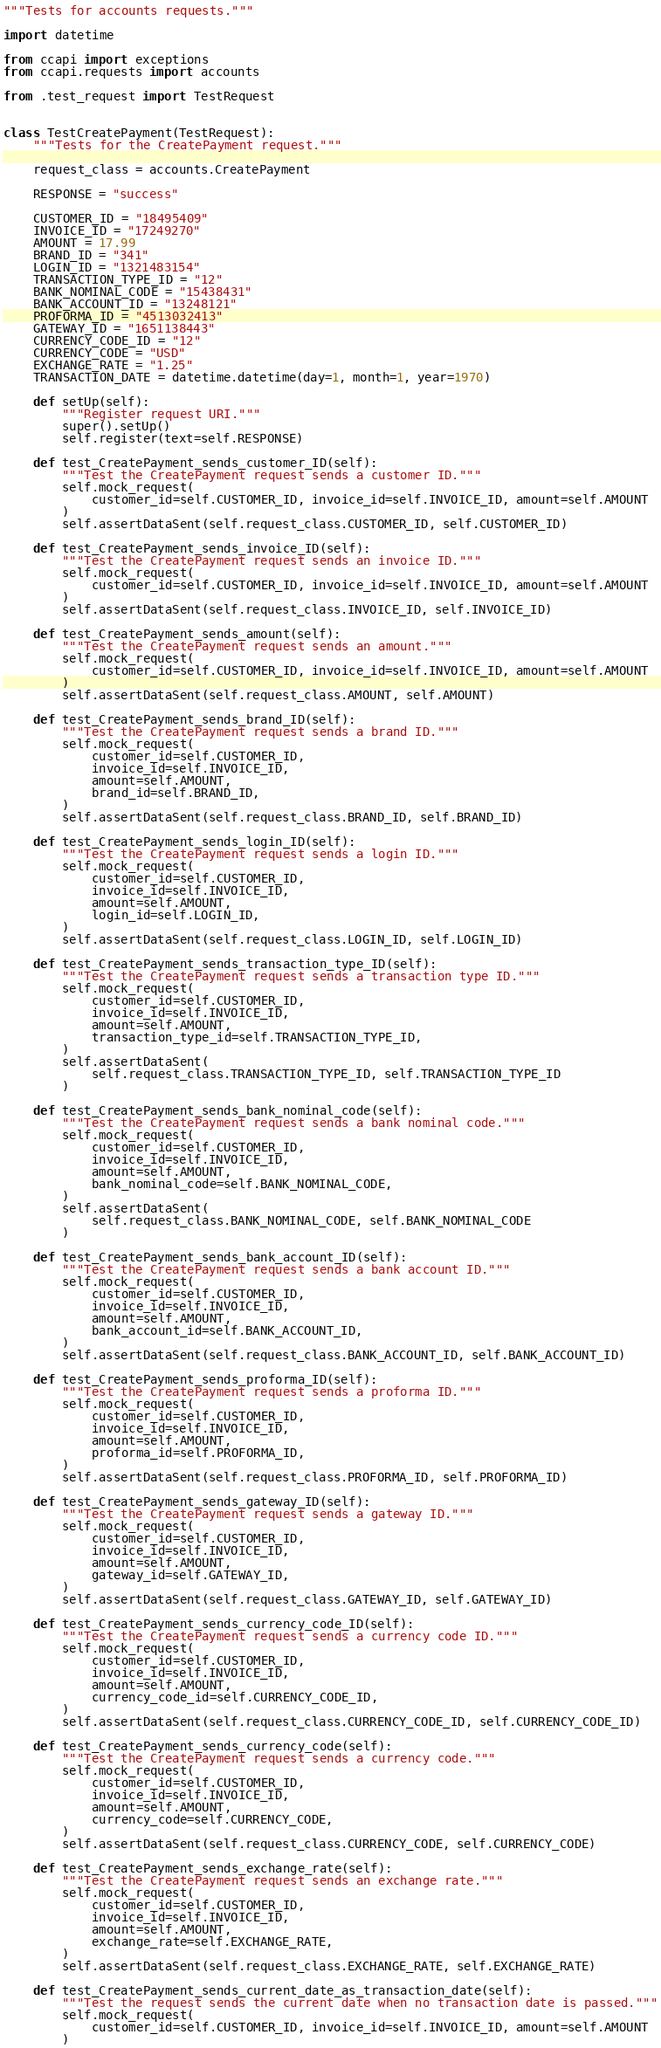Convert code to text. <code><loc_0><loc_0><loc_500><loc_500><_Python_>"""Tests for accounts requests."""

import datetime

from ccapi import exceptions
from ccapi.requests import accounts

from .test_request import TestRequest


class TestCreatePayment(TestRequest):
    """Tests for the CreatePayment request."""

    request_class = accounts.CreatePayment

    RESPONSE = "success"

    CUSTOMER_ID = "18495409"
    INVOICE_ID = "17249270"
    AMOUNT = 17.99
    BRAND_ID = "341"
    LOGIN_ID = "1321483154"
    TRANSACTION_TYPE_ID = "12"
    BANK_NOMINAL_CODE = "15438431"
    BANK_ACCOUNT_ID = "13248121"
    PROFORMA_ID = "4513032413"
    GATEWAY_ID = "1651138443"
    CURRENCY_CODE_ID = "12"
    CURRENCY_CODE = "USD"
    EXCHANGE_RATE = "1.25"
    TRANSACTION_DATE = datetime.datetime(day=1, month=1, year=1970)

    def setUp(self):
        """Register request URI."""
        super().setUp()
        self.register(text=self.RESPONSE)

    def test_CreatePayment_sends_customer_ID(self):
        """Test the CreatePayment request sends a customer ID."""
        self.mock_request(
            customer_id=self.CUSTOMER_ID, invoice_id=self.INVOICE_ID, amount=self.AMOUNT
        )
        self.assertDataSent(self.request_class.CUSTOMER_ID, self.CUSTOMER_ID)

    def test_CreatePayment_sends_invoice_ID(self):
        """Test the CreatePayment request sends an invoice ID."""
        self.mock_request(
            customer_id=self.CUSTOMER_ID, invoice_id=self.INVOICE_ID, amount=self.AMOUNT
        )
        self.assertDataSent(self.request_class.INVOICE_ID, self.INVOICE_ID)

    def test_CreatePayment_sends_amount(self):
        """Test the CreatePayment request sends an amount."""
        self.mock_request(
            customer_id=self.CUSTOMER_ID, invoice_id=self.INVOICE_ID, amount=self.AMOUNT
        )
        self.assertDataSent(self.request_class.AMOUNT, self.AMOUNT)

    def test_CreatePayment_sends_brand_ID(self):
        """Test the CreatePayment request sends a brand ID."""
        self.mock_request(
            customer_id=self.CUSTOMER_ID,
            invoice_id=self.INVOICE_ID,
            amount=self.AMOUNT,
            brand_id=self.BRAND_ID,
        )
        self.assertDataSent(self.request_class.BRAND_ID, self.BRAND_ID)

    def test_CreatePayment_sends_login_ID(self):
        """Test the CreatePayment request sends a login ID."""
        self.mock_request(
            customer_id=self.CUSTOMER_ID,
            invoice_id=self.INVOICE_ID,
            amount=self.AMOUNT,
            login_id=self.LOGIN_ID,
        )
        self.assertDataSent(self.request_class.LOGIN_ID, self.LOGIN_ID)

    def test_CreatePayment_sends_transaction_type_ID(self):
        """Test the CreatePayment request sends a transaction type ID."""
        self.mock_request(
            customer_id=self.CUSTOMER_ID,
            invoice_id=self.INVOICE_ID,
            amount=self.AMOUNT,
            transaction_type_id=self.TRANSACTION_TYPE_ID,
        )
        self.assertDataSent(
            self.request_class.TRANSACTION_TYPE_ID, self.TRANSACTION_TYPE_ID
        )

    def test_CreatePayment_sends_bank_nominal_code(self):
        """Test the CreatePayment request sends a bank nominal code."""
        self.mock_request(
            customer_id=self.CUSTOMER_ID,
            invoice_id=self.INVOICE_ID,
            amount=self.AMOUNT,
            bank_nominal_code=self.BANK_NOMINAL_CODE,
        )
        self.assertDataSent(
            self.request_class.BANK_NOMINAL_CODE, self.BANK_NOMINAL_CODE
        )

    def test_CreatePayment_sends_bank_account_ID(self):
        """Test the CreatePayment request sends a bank account ID."""
        self.mock_request(
            customer_id=self.CUSTOMER_ID,
            invoice_id=self.INVOICE_ID,
            amount=self.AMOUNT,
            bank_account_id=self.BANK_ACCOUNT_ID,
        )
        self.assertDataSent(self.request_class.BANK_ACCOUNT_ID, self.BANK_ACCOUNT_ID)

    def test_CreatePayment_sends_proforma_ID(self):
        """Test the CreatePayment request sends a proforma ID."""
        self.mock_request(
            customer_id=self.CUSTOMER_ID,
            invoice_id=self.INVOICE_ID,
            amount=self.AMOUNT,
            proforma_id=self.PROFORMA_ID,
        )
        self.assertDataSent(self.request_class.PROFORMA_ID, self.PROFORMA_ID)

    def test_CreatePayment_sends_gateway_ID(self):
        """Test the CreatePayment request sends a gateway ID."""
        self.mock_request(
            customer_id=self.CUSTOMER_ID,
            invoice_id=self.INVOICE_ID,
            amount=self.AMOUNT,
            gateway_id=self.GATEWAY_ID,
        )
        self.assertDataSent(self.request_class.GATEWAY_ID, self.GATEWAY_ID)

    def test_CreatePayment_sends_currency_code_ID(self):
        """Test the CreatePayment request sends a currency code ID."""
        self.mock_request(
            customer_id=self.CUSTOMER_ID,
            invoice_id=self.INVOICE_ID,
            amount=self.AMOUNT,
            currency_code_id=self.CURRENCY_CODE_ID,
        )
        self.assertDataSent(self.request_class.CURRENCY_CODE_ID, self.CURRENCY_CODE_ID)

    def test_CreatePayment_sends_currency_code(self):
        """Test the CreatePayment request sends a currency code."""
        self.mock_request(
            customer_id=self.CUSTOMER_ID,
            invoice_id=self.INVOICE_ID,
            amount=self.AMOUNT,
            currency_code=self.CURRENCY_CODE,
        )
        self.assertDataSent(self.request_class.CURRENCY_CODE, self.CURRENCY_CODE)

    def test_CreatePayment_sends_exchange_rate(self):
        """Test the CreatePayment request sends an exchange rate."""
        self.mock_request(
            customer_id=self.CUSTOMER_ID,
            invoice_id=self.INVOICE_ID,
            amount=self.AMOUNT,
            exchange_rate=self.EXCHANGE_RATE,
        )
        self.assertDataSent(self.request_class.EXCHANGE_RATE, self.EXCHANGE_RATE)

    def test_CreatePayment_sends_current_date_as_transaction_date(self):
        """Test the request sends the current date when no transaction date is passed."""
        self.mock_request(
            customer_id=self.CUSTOMER_ID, invoice_id=self.INVOICE_ID, amount=self.AMOUNT
        )</code> 